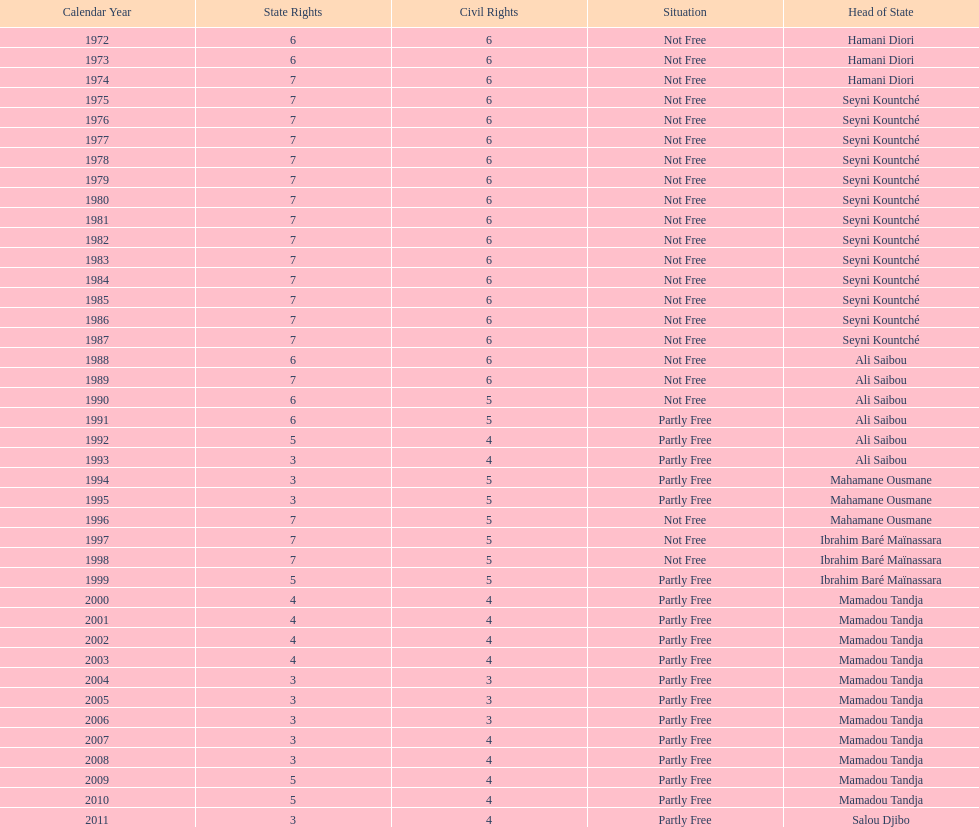What duration was needed for civil liberties to decline below 6? 18 years. 